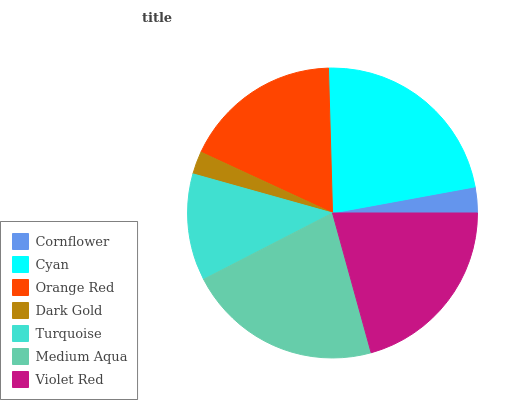Is Dark Gold the minimum?
Answer yes or no. Yes. Is Cyan the maximum?
Answer yes or no. Yes. Is Orange Red the minimum?
Answer yes or no. No. Is Orange Red the maximum?
Answer yes or no. No. Is Cyan greater than Orange Red?
Answer yes or no. Yes. Is Orange Red less than Cyan?
Answer yes or no. Yes. Is Orange Red greater than Cyan?
Answer yes or no. No. Is Cyan less than Orange Red?
Answer yes or no. No. Is Orange Red the high median?
Answer yes or no. Yes. Is Orange Red the low median?
Answer yes or no. Yes. Is Medium Aqua the high median?
Answer yes or no. No. Is Turquoise the low median?
Answer yes or no. No. 